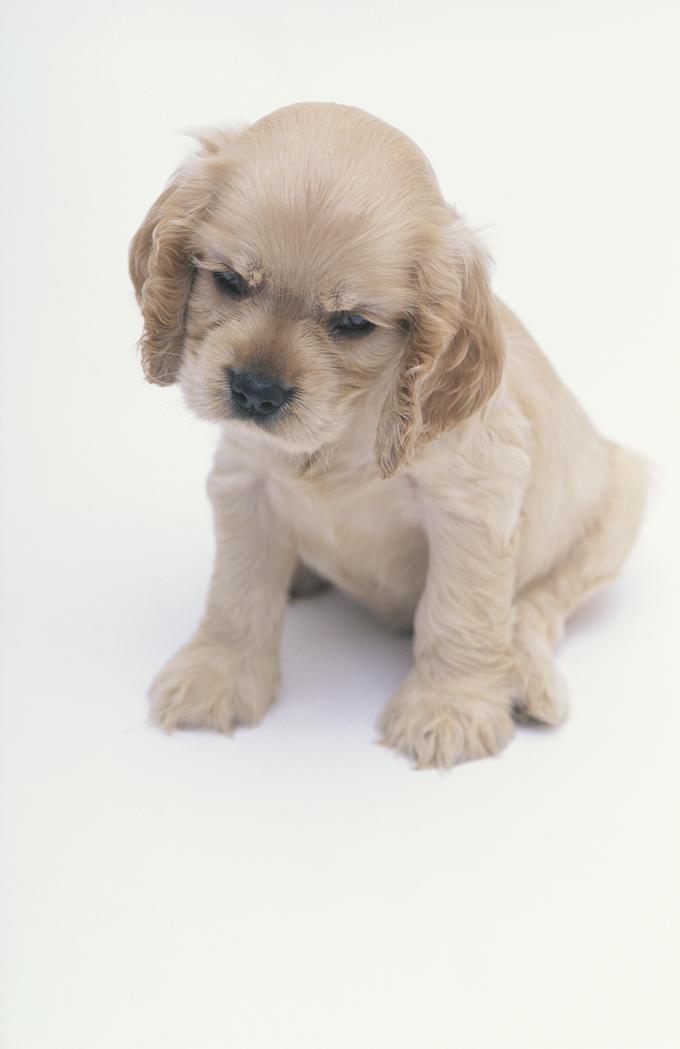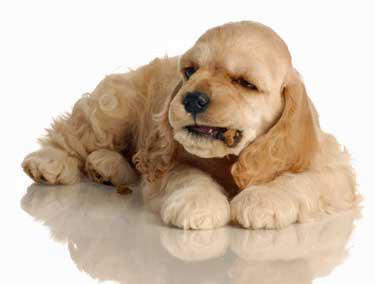The first image is the image on the left, the second image is the image on the right. Considering the images on both sides, is "One of the dogs is near the grass." valid? Answer yes or no. No. 